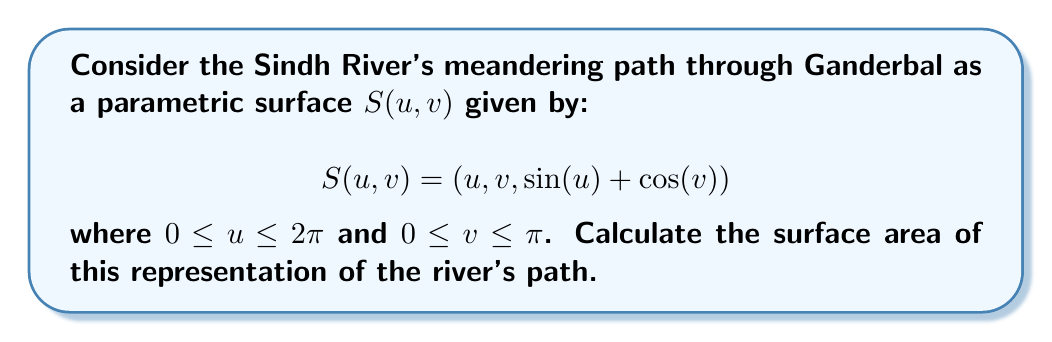Give your solution to this math problem. To calculate the surface area, we need to use the formula:

$$A = \int\int_D \left|\frac{\partial S}{\partial u} \times \frac{\partial S}{\partial v}\right| du dv$$

where $D$ is the domain of the parameters.

Step 1: Calculate the partial derivatives
$$\frac{\partial S}{\partial u} = (1, 0, \cos(u))$$
$$\frac{\partial S}{\partial v} = (0, 1, -\sin(v))$$

Step 2: Calculate the cross product
$$\frac{\partial S}{\partial u} \times \frac{\partial S}{\partial v} = (-\cos(u), -\sin(v), 1)$$

Step 3: Calculate the magnitude of the cross product
$$\left|\frac{\partial S}{\partial u} \times \frac{\partial S}{\partial v}\right| = \sqrt{\cos^2(u) + \sin^2(v) + 1}$$

Step 4: Set up the double integral
$$A = \int_0^\pi \int_0^{2\pi} \sqrt{\cos^2(u) + \sin^2(v) + 1} du dv$$

Step 5: This integral cannot be solved analytically, so we need to use numerical methods. Using a computer algebra system or numerical integration techniques, we can approximate the result to:

$$A \approx 13.3516$$

This value represents the surface area of the meandering path of the Sindh River through Ganderbal in square units, based on our parametric surface model.
Answer: $13.3516$ square units 